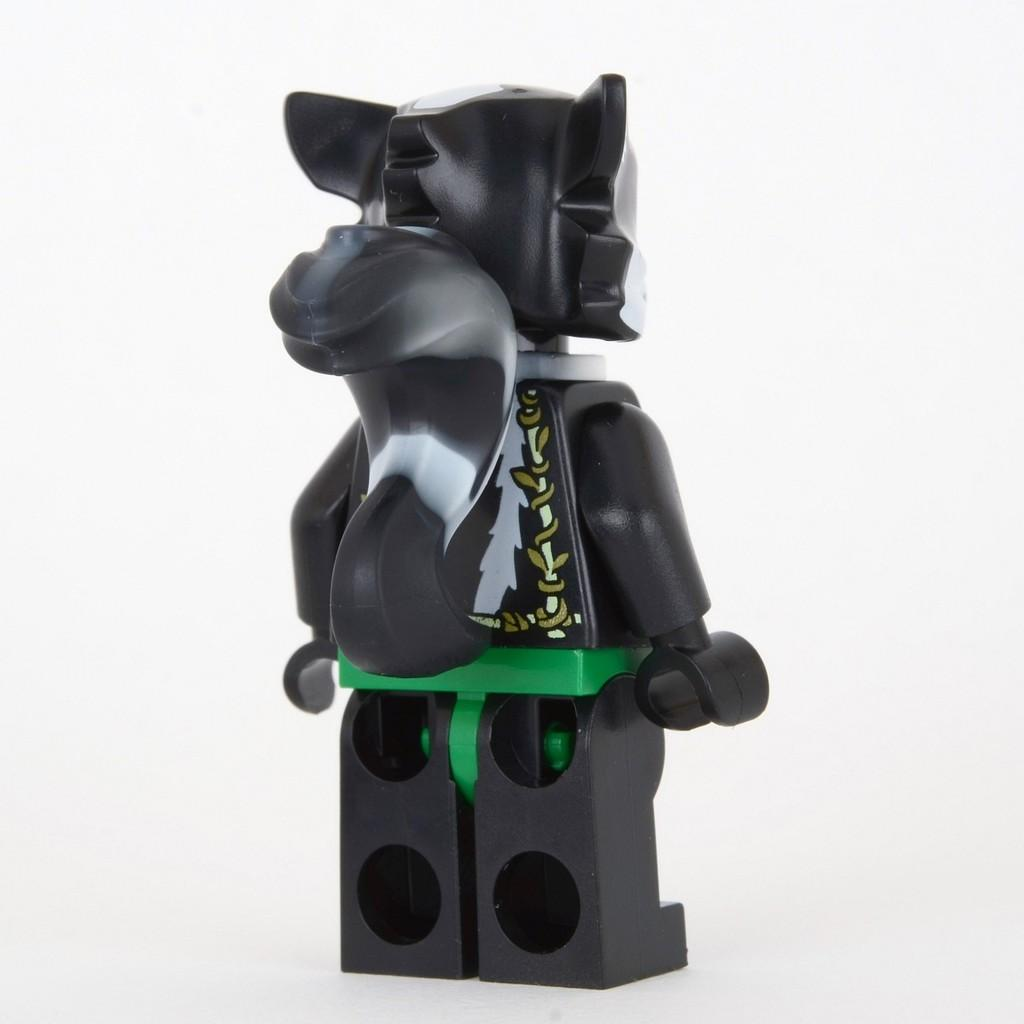What is the color of the toy in the image? The toy in the image is black. What color is the background of the image? The background of the image is white. Is there any blood visible on the toy in the image? No, there is no blood visible on the toy in the image. What type of discussion is taking place in the image? There is no discussion taking place in the image; it only features a black toy against a white background. 